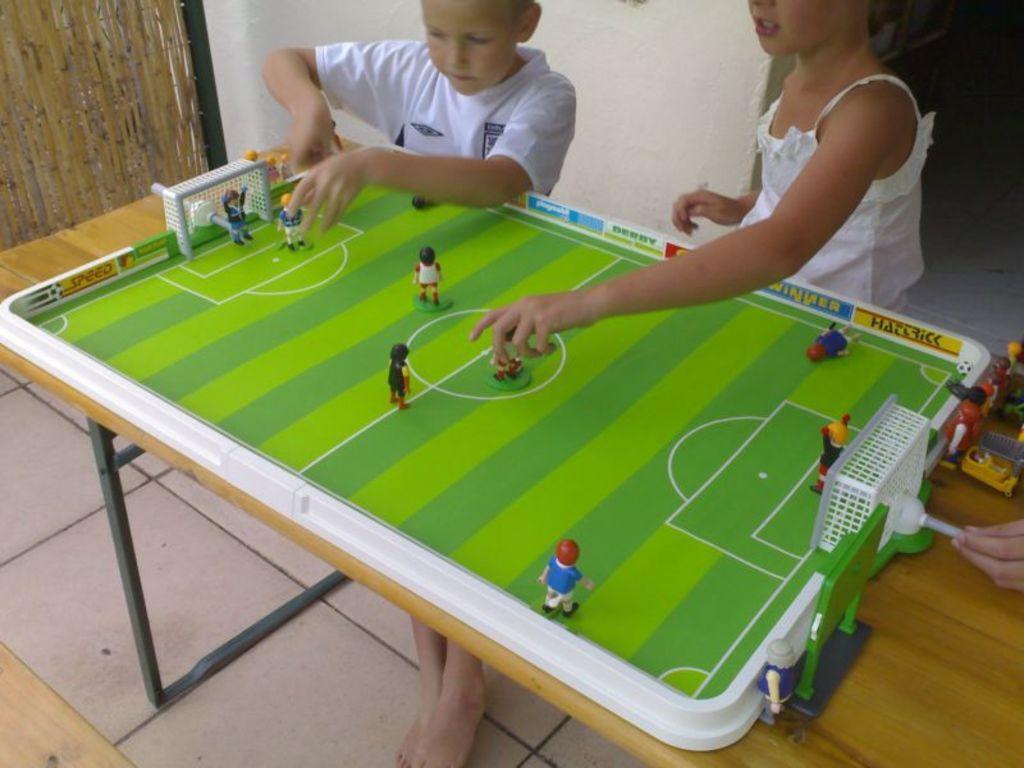In one or two sentences, can you explain what this image depicts? This picture is of inside the room. In the foreground there is a table, on the top of which there is a miniature with players playing football. On the right there is a girl standing and playing the game. On the left there is a boy wearing white color t-shirt and playing the game. In the background we can see a wall. 